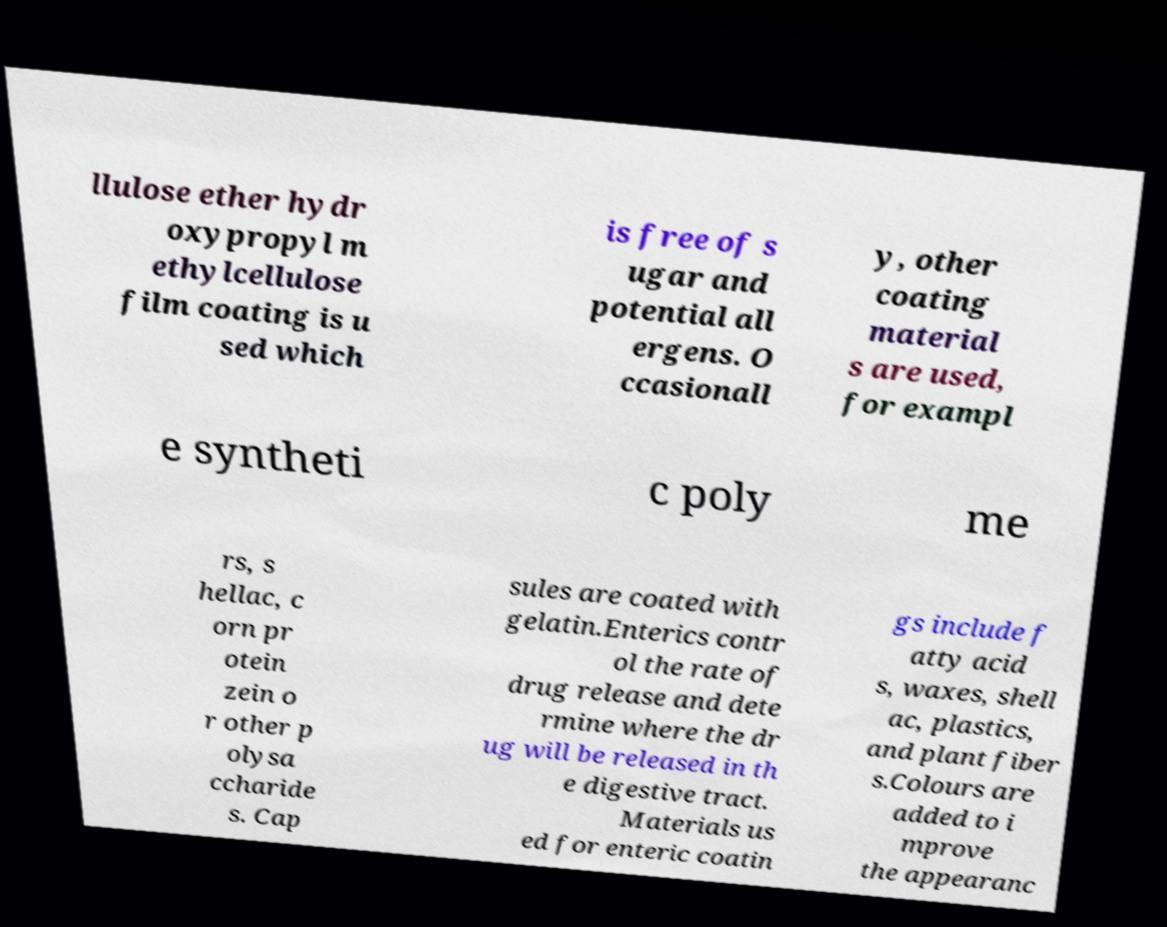For documentation purposes, I need the text within this image transcribed. Could you provide that? llulose ether hydr oxypropyl m ethylcellulose film coating is u sed which is free of s ugar and potential all ergens. O ccasionall y, other coating material s are used, for exampl e syntheti c poly me rs, s hellac, c orn pr otein zein o r other p olysa ccharide s. Cap sules are coated with gelatin.Enterics contr ol the rate of drug release and dete rmine where the dr ug will be released in th e digestive tract. Materials us ed for enteric coatin gs include f atty acid s, waxes, shell ac, plastics, and plant fiber s.Colours are added to i mprove the appearanc 